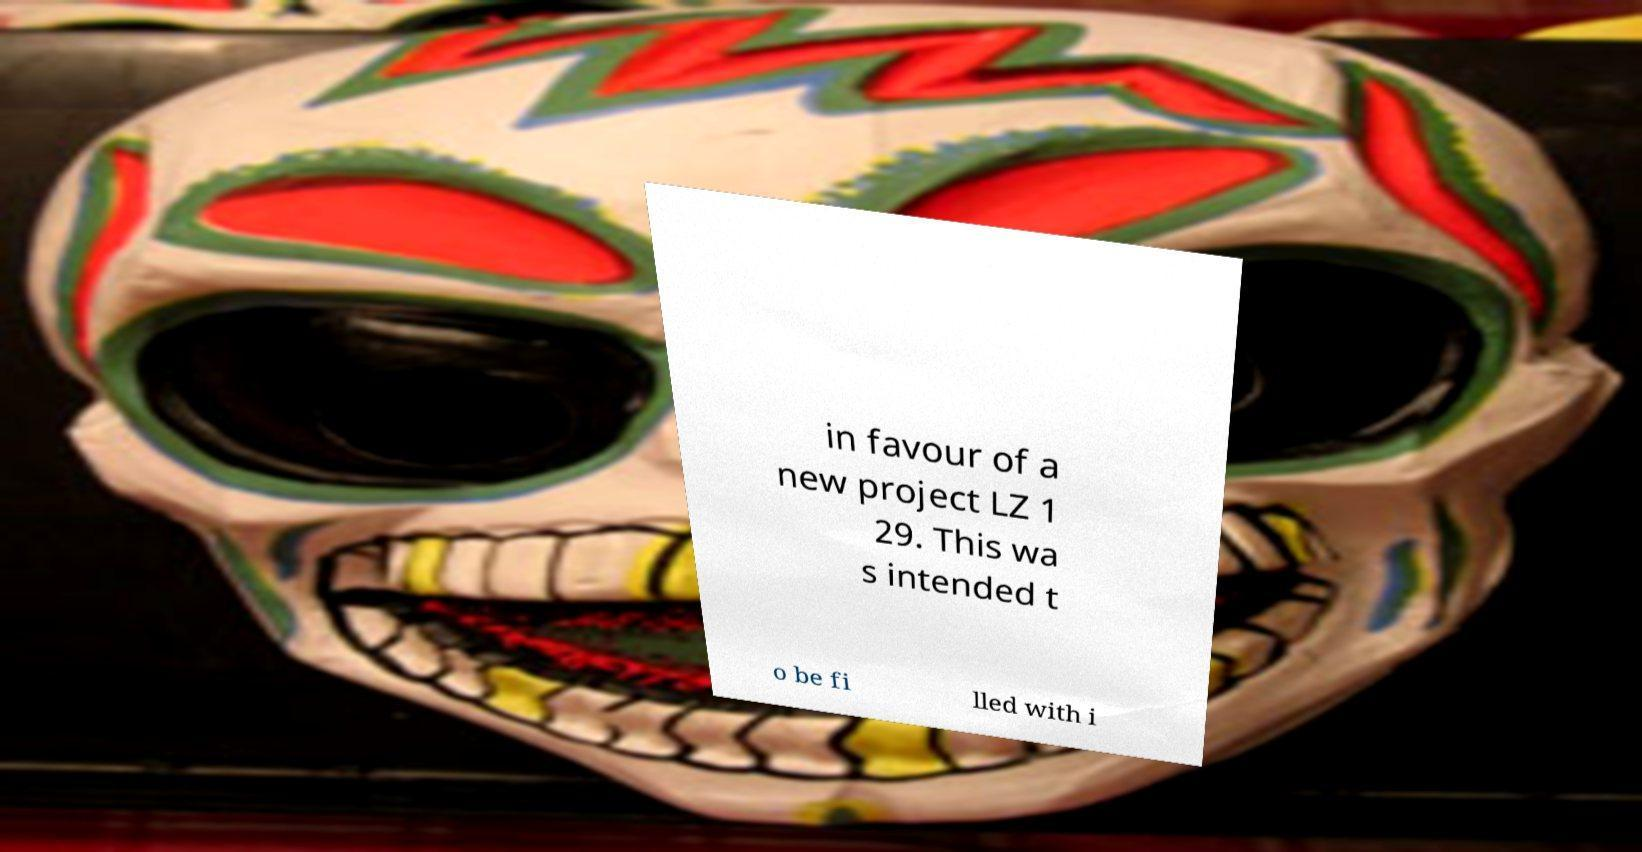For documentation purposes, I need the text within this image transcribed. Could you provide that? in favour of a new project LZ 1 29. This wa s intended t o be fi lled with i 